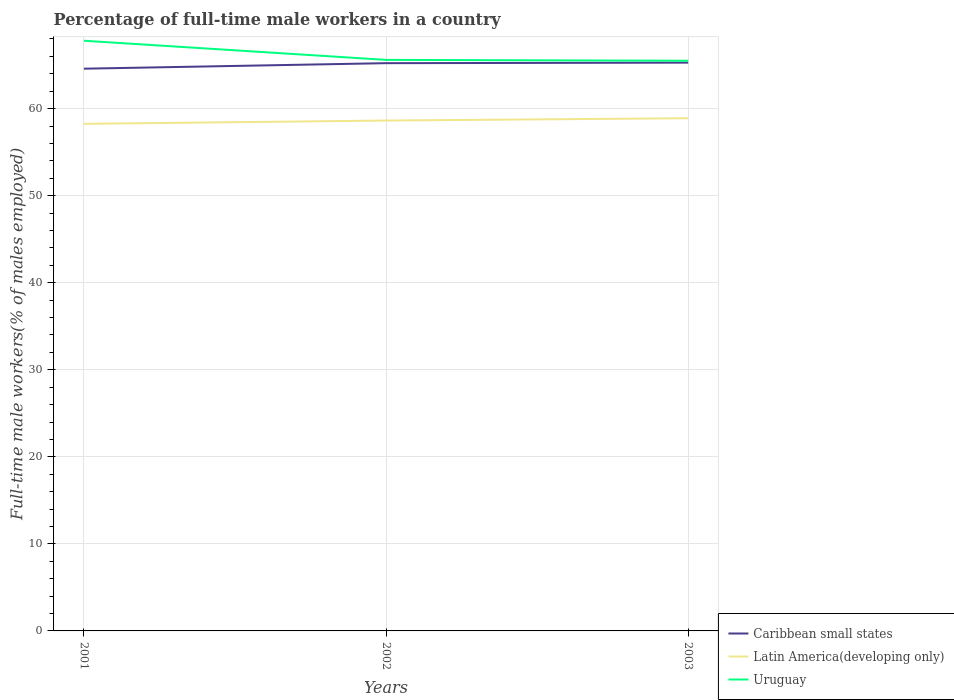Does the line corresponding to Caribbean small states intersect with the line corresponding to Uruguay?
Your response must be concise. No. Across all years, what is the maximum percentage of full-time male workers in Caribbean small states?
Your response must be concise. 64.59. What is the total percentage of full-time male workers in Uruguay in the graph?
Ensure brevity in your answer.  2.2. What is the difference between the highest and the second highest percentage of full-time male workers in Latin America(developing only)?
Your response must be concise. 0.64. What is the difference between the highest and the lowest percentage of full-time male workers in Latin America(developing only)?
Make the answer very short. 2. How many lines are there?
Your answer should be compact. 3. What is the difference between two consecutive major ticks on the Y-axis?
Keep it short and to the point. 10. Does the graph contain any zero values?
Give a very brief answer. No. Where does the legend appear in the graph?
Your answer should be very brief. Bottom right. How many legend labels are there?
Your answer should be compact. 3. How are the legend labels stacked?
Your answer should be very brief. Vertical. What is the title of the graph?
Ensure brevity in your answer.  Percentage of full-time male workers in a country. Does "Kosovo" appear as one of the legend labels in the graph?
Offer a very short reply. No. What is the label or title of the Y-axis?
Provide a short and direct response. Full-time male workers(% of males employed). What is the Full-time male workers(% of males employed) of Caribbean small states in 2001?
Your answer should be compact. 64.59. What is the Full-time male workers(% of males employed) in Latin America(developing only) in 2001?
Provide a short and direct response. 58.25. What is the Full-time male workers(% of males employed) in Uruguay in 2001?
Your answer should be very brief. 67.8. What is the Full-time male workers(% of males employed) of Caribbean small states in 2002?
Provide a short and direct response. 65.22. What is the Full-time male workers(% of males employed) of Latin America(developing only) in 2002?
Your answer should be very brief. 58.63. What is the Full-time male workers(% of males employed) of Uruguay in 2002?
Keep it short and to the point. 65.6. What is the Full-time male workers(% of males employed) of Caribbean small states in 2003?
Provide a short and direct response. 65.28. What is the Full-time male workers(% of males employed) of Latin America(developing only) in 2003?
Provide a succinct answer. 58.9. What is the Full-time male workers(% of males employed) in Uruguay in 2003?
Provide a succinct answer. 65.5. Across all years, what is the maximum Full-time male workers(% of males employed) of Caribbean small states?
Give a very brief answer. 65.28. Across all years, what is the maximum Full-time male workers(% of males employed) in Latin America(developing only)?
Offer a very short reply. 58.9. Across all years, what is the maximum Full-time male workers(% of males employed) of Uruguay?
Your answer should be compact. 67.8. Across all years, what is the minimum Full-time male workers(% of males employed) in Caribbean small states?
Offer a very short reply. 64.59. Across all years, what is the minimum Full-time male workers(% of males employed) in Latin America(developing only)?
Give a very brief answer. 58.25. Across all years, what is the minimum Full-time male workers(% of males employed) in Uruguay?
Your response must be concise. 65.5. What is the total Full-time male workers(% of males employed) in Caribbean small states in the graph?
Your answer should be compact. 195.09. What is the total Full-time male workers(% of males employed) in Latin America(developing only) in the graph?
Provide a short and direct response. 175.78. What is the total Full-time male workers(% of males employed) in Uruguay in the graph?
Keep it short and to the point. 198.9. What is the difference between the Full-time male workers(% of males employed) in Caribbean small states in 2001 and that in 2002?
Provide a short and direct response. -0.63. What is the difference between the Full-time male workers(% of males employed) of Latin America(developing only) in 2001 and that in 2002?
Provide a succinct answer. -0.38. What is the difference between the Full-time male workers(% of males employed) of Uruguay in 2001 and that in 2002?
Your answer should be very brief. 2.2. What is the difference between the Full-time male workers(% of males employed) of Caribbean small states in 2001 and that in 2003?
Your answer should be very brief. -0.7. What is the difference between the Full-time male workers(% of males employed) in Latin America(developing only) in 2001 and that in 2003?
Give a very brief answer. -0.64. What is the difference between the Full-time male workers(% of males employed) of Uruguay in 2001 and that in 2003?
Make the answer very short. 2.3. What is the difference between the Full-time male workers(% of males employed) in Caribbean small states in 2002 and that in 2003?
Offer a terse response. -0.06. What is the difference between the Full-time male workers(% of males employed) of Latin America(developing only) in 2002 and that in 2003?
Make the answer very short. -0.27. What is the difference between the Full-time male workers(% of males employed) of Caribbean small states in 2001 and the Full-time male workers(% of males employed) of Latin America(developing only) in 2002?
Your answer should be compact. 5.96. What is the difference between the Full-time male workers(% of males employed) in Caribbean small states in 2001 and the Full-time male workers(% of males employed) in Uruguay in 2002?
Provide a short and direct response. -1.01. What is the difference between the Full-time male workers(% of males employed) of Latin America(developing only) in 2001 and the Full-time male workers(% of males employed) of Uruguay in 2002?
Ensure brevity in your answer.  -7.35. What is the difference between the Full-time male workers(% of males employed) in Caribbean small states in 2001 and the Full-time male workers(% of males employed) in Latin America(developing only) in 2003?
Offer a very short reply. 5.69. What is the difference between the Full-time male workers(% of males employed) in Caribbean small states in 2001 and the Full-time male workers(% of males employed) in Uruguay in 2003?
Your response must be concise. -0.91. What is the difference between the Full-time male workers(% of males employed) of Latin America(developing only) in 2001 and the Full-time male workers(% of males employed) of Uruguay in 2003?
Keep it short and to the point. -7.25. What is the difference between the Full-time male workers(% of males employed) in Caribbean small states in 2002 and the Full-time male workers(% of males employed) in Latin America(developing only) in 2003?
Your answer should be compact. 6.33. What is the difference between the Full-time male workers(% of males employed) of Caribbean small states in 2002 and the Full-time male workers(% of males employed) of Uruguay in 2003?
Make the answer very short. -0.28. What is the difference between the Full-time male workers(% of males employed) in Latin America(developing only) in 2002 and the Full-time male workers(% of males employed) in Uruguay in 2003?
Ensure brevity in your answer.  -6.87. What is the average Full-time male workers(% of males employed) of Caribbean small states per year?
Provide a short and direct response. 65.03. What is the average Full-time male workers(% of males employed) in Latin America(developing only) per year?
Give a very brief answer. 58.59. What is the average Full-time male workers(% of males employed) in Uruguay per year?
Ensure brevity in your answer.  66.3. In the year 2001, what is the difference between the Full-time male workers(% of males employed) in Caribbean small states and Full-time male workers(% of males employed) in Latin America(developing only)?
Offer a very short reply. 6.33. In the year 2001, what is the difference between the Full-time male workers(% of males employed) of Caribbean small states and Full-time male workers(% of males employed) of Uruguay?
Provide a short and direct response. -3.21. In the year 2001, what is the difference between the Full-time male workers(% of males employed) in Latin America(developing only) and Full-time male workers(% of males employed) in Uruguay?
Ensure brevity in your answer.  -9.55. In the year 2002, what is the difference between the Full-time male workers(% of males employed) in Caribbean small states and Full-time male workers(% of males employed) in Latin America(developing only)?
Your response must be concise. 6.59. In the year 2002, what is the difference between the Full-time male workers(% of males employed) of Caribbean small states and Full-time male workers(% of males employed) of Uruguay?
Your answer should be compact. -0.38. In the year 2002, what is the difference between the Full-time male workers(% of males employed) in Latin America(developing only) and Full-time male workers(% of males employed) in Uruguay?
Offer a terse response. -6.97. In the year 2003, what is the difference between the Full-time male workers(% of males employed) of Caribbean small states and Full-time male workers(% of males employed) of Latin America(developing only)?
Make the answer very short. 6.39. In the year 2003, what is the difference between the Full-time male workers(% of males employed) of Caribbean small states and Full-time male workers(% of males employed) of Uruguay?
Provide a short and direct response. -0.22. In the year 2003, what is the difference between the Full-time male workers(% of males employed) of Latin America(developing only) and Full-time male workers(% of males employed) of Uruguay?
Ensure brevity in your answer.  -6.6. What is the ratio of the Full-time male workers(% of males employed) of Caribbean small states in 2001 to that in 2002?
Offer a very short reply. 0.99. What is the ratio of the Full-time male workers(% of males employed) in Uruguay in 2001 to that in 2002?
Offer a terse response. 1.03. What is the ratio of the Full-time male workers(% of males employed) in Caribbean small states in 2001 to that in 2003?
Offer a very short reply. 0.99. What is the ratio of the Full-time male workers(% of males employed) in Uruguay in 2001 to that in 2003?
Provide a short and direct response. 1.04. What is the difference between the highest and the second highest Full-time male workers(% of males employed) in Caribbean small states?
Keep it short and to the point. 0.06. What is the difference between the highest and the second highest Full-time male workers(% of males employed) in Latin America(developing only)?
Your answer should be very brief. 0.27. What is the difference between the highest and the second highest Full-time male workers(% of males employed) of Uruguay?
Your response must be concise. 2.2. What is the difference between the highest and the lowest Full-time male workers(% of males employed) in Caribbean small states?
Offer a terse response. 0.7. What is the difference between the highest and the lowest Full-time male workers(% of males employed) of Latin America(developing only)?
Ensure brevity in your answer.  0.64. What is the difference between the highest and the lowest Full-time male workers(% of males employed) in Uruguay?
Provide a short and direct response. 2.3. 